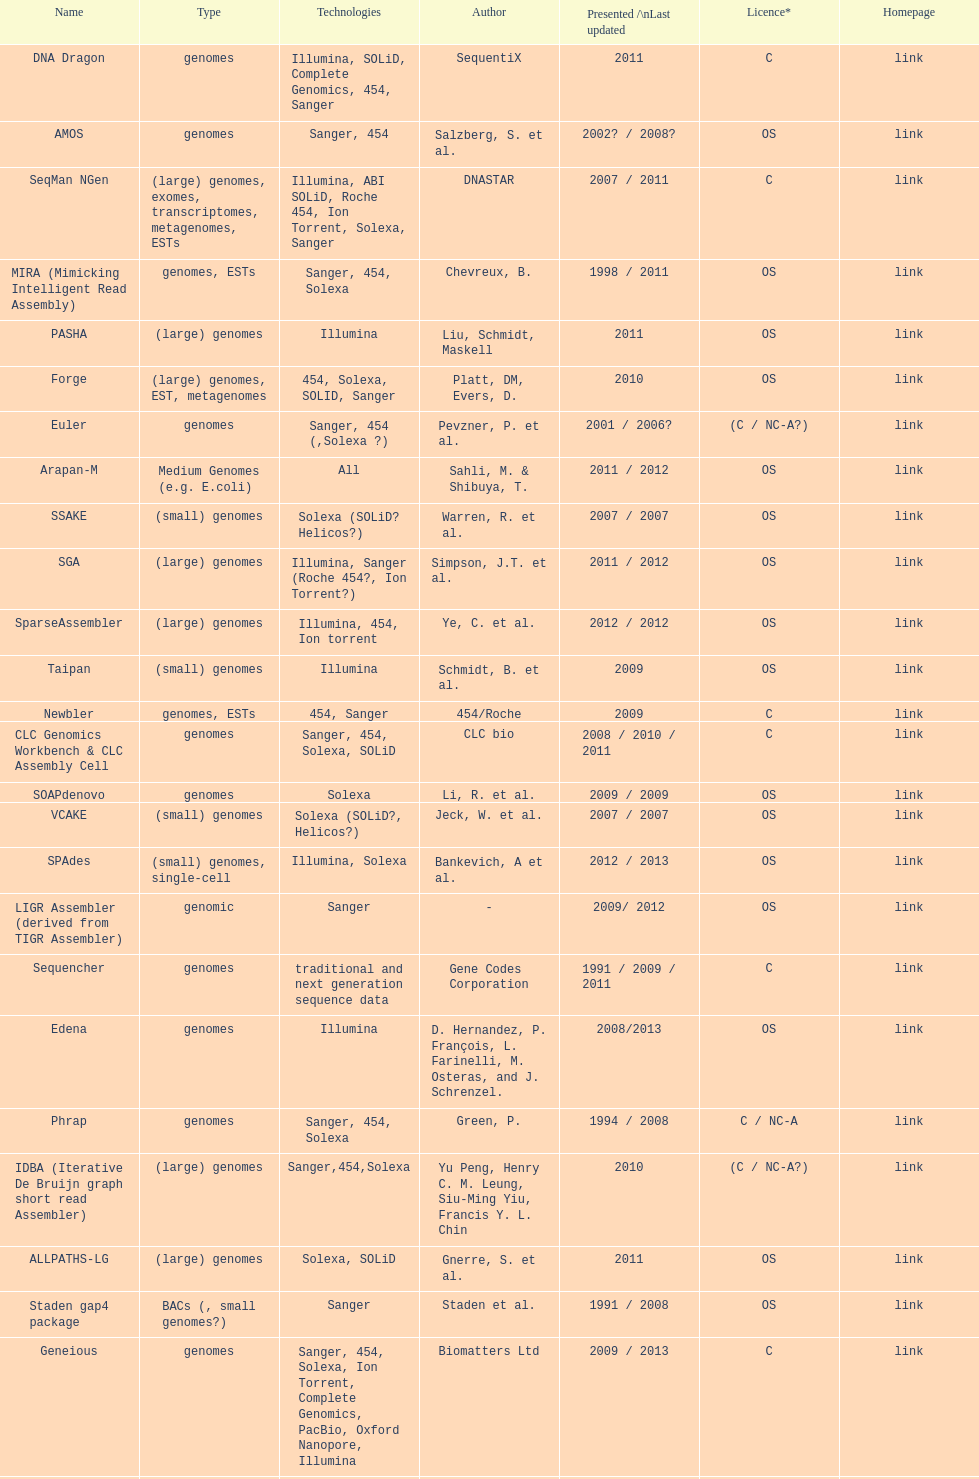Would you mind parsing the complete table? {'header': ['Name', 'Type', 'Technologies', 'Author', 'Presented /\\nLast updated', 'Licence*', 'Homepage'], 'rows': [['DNA Dragon', 'genomes', 'Illumina, SOLiD, Complete Genomics, 454, Sanger', 'SequentiX', '2011', 'C', 'link'], ['AMOS', 'genomes', 'Sanger, 454', 'Salzberg, S. et al.', '2002? / 2008?', 'OS', 'link'], ['SeqMan NGen', '(large) genomes, exomes, transcriptomes, metagenomes, ESTs', 'Illumina, ABI SOLiD, Roche 454, Ion Torrent, Solexa, Sanger', 'DNASTAR', '2007 / 2011', 'C', 'link'], ['MIRA (Mimicking Intelligent Read Assembly)', 'genomes, ESTs', 'Sanger, 454, Solexa', 'Chevreux, B.', '1998 / 2011', 'OS', 'link'], ['PASHA', '(large) genomes', 'Illumina', 'Liu, Schmidt, Maskell', '2011', 'OS', 'link'], ['Forge', '(large) genomes, EST, metagenomes', '454, Solexa, SOLID, Sanger', 'Platt, DM, Evers, D.', '2010', 'OS', 'link'], ['Euler', 'genomes', 'Sanger, 454 (,Solexa\xa0?)', 'Pevzner, P. et al.', '2001 / 2006?', '(C / NC-A?)', 'link'], ['Arapan-M', 'Medium Genomes (e.g. E.coli)', 'All', 'Sahli, M. & Shibuya, T.', '2011 / 2012', 'OS', 'link'], ['SSAKE', '(small) genomes', 'Solexa (SOLiD? Helicos?)', 'Warren, R. et al.', '2007 / 2007', 'OS', 'link'], ['SGA', '(large) genomes', 'Illumina, Sanger (Roche 454?, Ion Torrent?)', 'Simpson, J.T. et al.', '2011 / 2012', 'OS', 'link'], ['SparseAssembler', '(large) genomes', 'Illumina, 454, Ion torrent', 'Ye, C. et al.', '2012 / 2012', 'OS', 'link'], ['Taipan', '(small) genomes', 'Illumina', 'Schmidt, B. et al.', '2009', 'OS', 'link'], ['Newbler', 'genomes, ESTs', '454, Sanger', '454/Roche', '2009', 'C', 'link'], ['CLC Genomics Workbench & CLC Assembly Cell', 'genomes', 'Sanger, 454, Solexa, SOLiD', 'CLC bio', '2008 / 2010 / 2011', 'C', 'link'], ['SOAPdenovo', 'genomes', 'Solexa', 'Li, R. et al.', '2009 / 2009', 'OS', 'link'], ['VCAKE', '(small) genomes', 'Solexa (SOLiD?, Helicos?)', 'Jeck, W. et al.', '2007 / 2007', 'OS', 'link'], ['SPAdes', '(small) genomes, single-cell', 'Illumina, Solexa', 'Bankevich, A et al.', '2012 / 2013', 'OS', 'link'], ['LIGR Assembler (derived from TIGR Assembler)', 'genomic', 'Sanger', '-', '2009/ 2012', 'OS', 'link'], ['Sequencher', 'genomes', 'traditional and next generation sequence data', 'Gene Codes Corporation', '1991 / 2009 / 2011', 'C', 'link'], ['Edena', 'genomes', 'Illumina', 'D. Hernandez, P. François, L. Farinelli, M. Osteras, and J. Schrenzel.', '2008/2013', 'OS', 'link'], ['Phrap', 'genomes', 'Sanger, 454, Solexa', 'Green, P.', '1994 / 2008', 'C / NC-A', 'link'], ['IDBA (Iterative De Bruijn graph short read Assembler)', '(large) genomes', 'Sanger,454,Solexa', 'Yu Peng, Henry C. M. Leung, Siu-Ming Yiu, Francis Y. L. Chin', '2010', '(C / NC-A?)', 'link'], ['ALLPATHS-LG', '(large) genomes', 'Solexa, SOLiD', 'Gnerre, S. et al.', '2011', 'OS', 'link'], ['Staden gap4 package', 'BACs (, small genomes?)', 'Sanger', 'Staden et al.', '1991 / 2008', 'OS', 'link'], ['Geneious', 'genomes', 'Sanger, 454, Solexa, Ion Torrent, Complete Genomics, PacBio, Oxford Nanopore, Illumina', 'Biomatters Ltd', '2009 / 2013', 'C', 'link'], ['MaSuRCA (Maryland Super Read - Celera Assembler)', '(large) genomes', 'Sanger, Illumina, 454', 'Aleksey Zimin, Guillaume Marçais, Daniela Puiu, Michael Roberts, Steven L. Salzberg, James A. Yorke', '2012 / 2013', 'OS', 'link'], ['DNAnexus', 'genomes', 'Illumina, SOLiD, Complete Genomics', 'DNAnexus', '2011', 'C', 'link'], ['NextGENe', '(small genomes?)', '454, Solexa, SOLiD', 'Softgenetics', '2008', 'C', 'link'], ['PADENA', 'genomes', '454, Sanger', '454/Roche', '2010', 'OS', 'link'], ['ABySS', '(large) genomes', 'Solexa, SOLiD', 'Simpson, J. et al.', '2008 / 2011', 'NC-A', 'link'], ['TIGR Assembler', 'genomic', 'Sanger', '-', '1995 / 2003', 'OS', 'link'], ['Velvet', '(small) genomes', 'Sanger, 454, Solexa, SOLiD', 'Zerbino, D. et al.', '2007 / 2009', 'OS', 'link'], ['SHARCGS', '(small) genomes', 'Solexa', 'Dohm et al.', '2007 / 2007', 'OS', 'link'], ['Celera WGA Assembler / CABOG', '(large) genomes', 'Sanger, 454, Solexa', 'Myers, G. et al.; Miller G. et al.', '2004 / 2010', 'OS', 'link'], ['Cortex', 'genomes', 'Solexa, SOLiD', 'Iqbal, Z. et al.', '2011', 'OS', 'link'], ['Quality Value Guided SRA (QSRA)', 'genomes', 'Sanger, Solexa', 'Bryant DW, et al.', '2009', 'OS', 'link'], ['Phusion assembler', '(large) genomes', 'Sanger', 'Mullikin JC, et al.', '2003', 'OS', 'link'], ['Euler-sr', 'genomes', '454, Solexa', 'Chaisson, MJ. et al.', '2008', 'NC-A', 'link'], ['Graph Constructor', '(large) genomes', 'Sanger, 454, Solexa, SOLiD', 'Convey Computer Corporation', '2011', 'C', 'link'], ['Arapan-S', 'Small Genomes (Viruses and Bacteria)', 'All', 'Sahli, M. & Shibuya, T.', '2011 / 2012', 'OS', 'link'], ['DNA Baser', 'genomes', 'Sanger, 454', 'Heracle BioSoft SRL', '01.2014', 'C', 'www.DnaBaser.com'], ['Ray', 'genomes', 'Illumina, mix of Illumina and 454, paired or not', 'Sébastien Boisvert, François Laviolette & Jacques Corbeil.', '2010', 'OS [GNU General Public License]', 'link'], ['SOPRA', 'genomes', 'Illumina, SOLiD, Sanger, 454', 'Dayarian, A. et al.', '2010 / 2011', 'OS', 'link']]} What is the total number of assemblers supporting medium genomes type technologies? 1. 